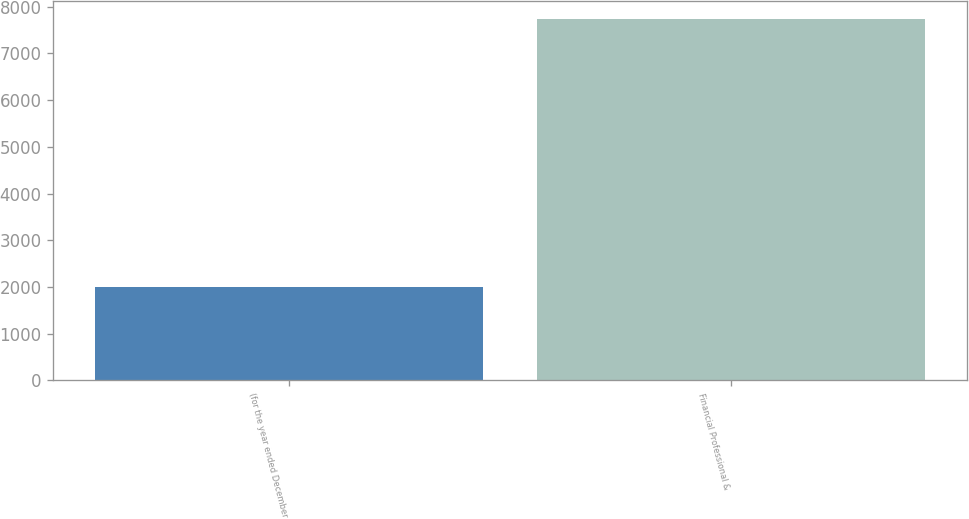Convert chart to OTSL. <chart><loc_0><loc_0><loc_500><loc_500><bar_chart><fcel>(for the year ended December<fcel>Financial Professional &<nl><fcel>2011<fcel>7745<nl></chart> 